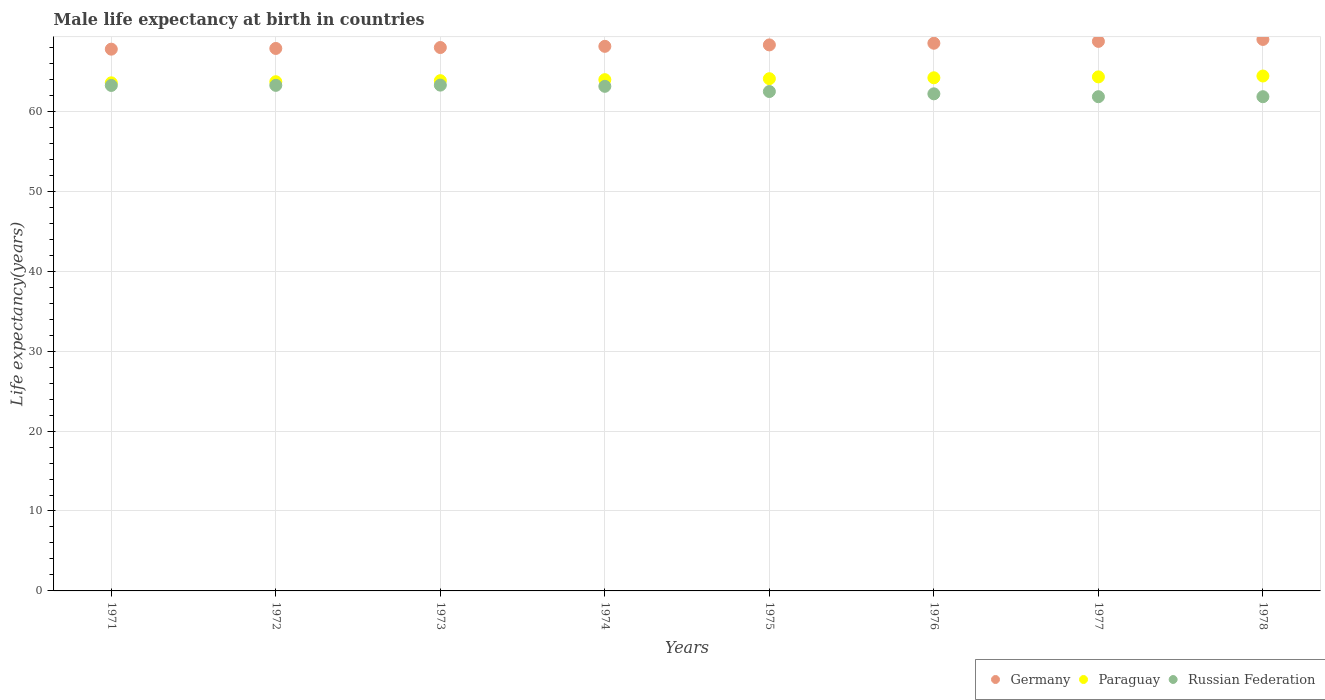What is the male life expectancy at birth in Russian Federation in 1971?
Provide a short and direct response. 63.24. Across all years, what is the maximum male life expectancy at birth in Paraguay?
Your answer should be very brief. 64.42. Across all years, what is the minimum male life expectancy at birth in Germany?
Ensure brevity in your answer.  67.78. In which year was the male life expectancy at birth in Germany maximum?
Your response must be concise. 1978. What is the total male life expectancy at birth in Germany in the graph?
Provide a short and direct response. 546.34. What is the difference between the male life expectancy at birth in Russian Federation in 1973 and that in 1978?
Keep it short and to the point. 1.45. What is the difference between the male life expectancy at birth in Russian Federation in 1973 and the male life expectancy at birth in Paraguay in 1978?
Offer a terse response. -1.14. What is the average male life expectancy at birth in Paraguay per year?
Give a very brief answer. 64.01. In the year 1978, what is the difference between the male life expectancy at birth in Paraguay and male life expectancy at birth in Russian Federation?
Offer a terse response. 2.59. What is the ratio of the male life expectancy at birth in Germany in 1974 to that in 1978?
Provide a short and direct response. 0.99. Is the male life expectancy at birth in Germany in 1972 less than that in 1974?
Keep it short and to the point. Yes. What is the difference between the highest and the second highest male life expectancy at birth in Germany?
Provide a succinct answer. 0.24. What is the difference between the highest and the lowest male life expectancy at birth in Russian Federation?
Your answer should be very brief. 1.45. In how many years, is the male life expectancy at birth in Paraguay greater than the average male life expectancy at birth in Paraguay taken over all years?
Make the answer very short. 4. Is it the case that in every year, the sum of the male life expectancy at birth in Germany and male life expectancy at birth in Paraguay  is greater than the male life expectancy at birth in Russian Federation?
Make the answer very short. Yes. Is the male life expectancy at birth in Germany strictly greater than the male life expectancy at birth in Russian Federation over the years?
Provide a succinct answer. Yes. Is the male life expectancy at birth in Russian Federation strictly less than the male life expectancy at birth in Germany over the years?
Offer a terse response. Yes. How many dotlines are there?
Your response must be concise. 3. How many years are there in the graph?
Ensure brevity in your answer.  8. What is the difference between two consecutive major ticks on the Y-axis?
Your response must be concise. 10. Does the graph contain any zero values?
Offer a terse response. No. How many legend labels are there?
Your answer should be compact. 3. What is the title of the graph?
Make the answer very short. Male life expectancy at birth in countries. Does "Montenegro" appear as one of the legend labels in the graph?
Your answer should be compact. No. What is the label or title of the Y-axis?
Your answer should be compact. Life expectancy(years). What is the Life expectancy(years) of Germany in 1971?
Ensure brevity in your answer.  67.78. What is the Life expectancy(years) in Paraguay in 1971?
Your answer should be very brief. 63.57. What is the Life expectancy(years) of Russian Federation in 1971?
Your answer should be very brief. 63.24. What is the Life expectancy(years) of Germany in 1972?
Offer a very short reply. 67.87. What is the Life expectancy(years) of Paraguay in 1972?
Provide a short and direct response. 63.7. What is the Life expectancy(years) in Russian Federation in 1972?
Offer a very short reply. 63.25. What is the Life expectancy(years) of Germany in 1973?
Your answer should be compact. 67.98. What is the Life expectancy(years) in Paraguay in 1973?
Your answer should be compact. 63.84. What is the Life expectancy(years) of Russian Federation in 1973?
Provide a succinct answer. 63.28. What is the Life expectancy(years) in Germany in 1974?
Make the answer very short. 68.13. What is the Life expectancy(years) in Paraguay in 1974?
Provide a succinct answer. 63.96. What is the Life expectancy(years) of Russian Federation in 1974?
Provide a short and direct response. 63.13. What is the Life expectancy(years) in Germany in 1975?
Provide a succinct answer. 68.31. What is the Life expectancy(years) of Paraguay in 1975?
Offer a very short reply. 64.08. What is the Life expectancy(years) in Russian Federation in 1975?
Offer a very short reply. 62.48. What is the Life expectancy(years) of Germany in 1976?
Your response must be concise. 68.52. What is the Life expectancy(years) of Paraguay in 1976?
Make the answer very short. 64.2. What is the Life expectancy(years) of Russian Federation in 1976?
Offer a very short reply. 62.19. What is the Life expectancy(years) in Germany in 1977?
Ensure brevity in your answer.  68.75. What is the Life expectancy(years) of Paraguay in 1977?
Your answer should be compact. 64.31. What is the Life expectancy(years) of Russian Federation in 1977?
Your answer should be very brief. 61.83. What is the Life expectancy(years) in Germany in 1978?
Your response must be concise. 69. What is the Life expectancy(years) of Paraguay in 1978?
Your answer should be very brief. 64.42. What is the Life expectancy(years) in Russian Federation in 1978?
Make the answer very short. 61.83. Across all years, what is the maximum Life expectancy(years) in Germany?
Your response must be concise. 69. Across all years, what is the maximum Life expectancy(years) of Paraguay?
Your answer should be compact. 64.42. Across all years, what is the maximum Life expectancy(years) of Russian Federation?
Keep it short and to the point. 63.28. Across all years, what is the minimum Life expectancy(years) in Germany?
Your answer should be very brief. 67.78. Across all years, what is the minimum Life expectancy(years) of Paraguay?
Give a very brief answer. 63.57. Across all years, what is the minimum Life expectancy(years) of Russian Federation?
Offer a terse response. 61.83. What is the total Life expectancy(years) of Germany in the graph?
Provide a short and direct response. 546.34. What is the total Life expectancy(years) in Paraguay in the graph?
Offer a terse response. 512.08. What is the total Life expectancy(years) in Russian Federation in the graph?
Keep it short and to the point. 501.23. What is the difference between the Life expectancy(years) in Germany in 1971 and that in 1972?
Your answer should be compact. -0.09. What is the difference between the Life expectancy(years) in Paraguay in 1971 and that in 1972?
Provide a short and direct response. -0.14. What is the difference between the Life expectancy(years) in Russian Federation in 1971 and that in 1972?
Provide a short and direct response. -0.01. What is the difference between the Life expectancy(years) of Germany in 1971 and that in 1973?
Ensure brevity in your answer.  -0.21. What is the difference between the Life expectancy(years) of Paraguay in 1971 and that in 1973?
Your answer should be compact. -0.27. What is the difference between the Life expectancy(years) of Russian Federation in 1971 and that in 1973?
Keep it short and to the point. -0.04. What is the difference between the Life expectancy(years) in Germany in 1971 and that in 1974?
Your response must be concise. -0.35. What is the difference between the Life expectancy(years) of Paraguay in 1971 and that in 1974?
Offer a terse response. -0.4. What is the difference between the Life expectancy(years) in Russian Federation in 1971 and that in 1974?
Your answer should be compact. 0.11. What is the difference between the Life expectancy(years) of Germany in 1971 and that in 1975?
Provide a succinct answer. -0.53. What is the difference between the Life expectancy(years) in Paraguay in 1971 and that in 1975?
Offer a very short reply. -0.52. What is the difference between the Life expectancy(years) in Russian Federation in 1971 and that in 1975?
Your answer should be very brief. 0.76. What is the difference between the Life expectancy(years) of Germany in 1971 and that in 1976?
Keep it short and to the point. -0.74. What is the difference between the Life expectancy(years) of Paraguay in 1971 and that in 1976?
Offer a terse response. -0.63. What is the difference between the Life expectancy(years) in Germany in 1971 and that in 1977?
Your response must be concise. -0.97. What is the difference between the Life expectancy(years) of Paraguay in 1971 and that in 1977?
Keep it short and to the point. -0.74. What is the difference between the Life expectancy(years) in Russian Federation in 1971 and that in 1977?
Keep it short and to the point. 1.41. What is the difference between the Life expectancy(years) of Germany in 1971 and that in 1978?
Keep it short and to the point. -1.22. What is the difference between the Life expectancy(years) in Paraguay in 1971 and that in 1978?
Your answer should be compact. -0.85. What is the difference between the Life expectancy(years) of Russian Federation in 1971 and that in 1978?
Offer a terse response. 1.41. What is the difference between the Life expectancy(years) of Germany in 1972 and that in 1973?
Keep it short and to the point. -0.12. What is the difference between the Life expectancy(years) of Paraguay in 1972 and that in 1973?
Offer a very short reply. -0.13. What is the difference between the Life expectancy(years) in Russian Federation in 1972 and that in 1973?
Offer a terse response. -0.03. What is the difference between the Life expectancy(years) in Germany in 1972 and that in 1974?
Provide a short and direct response. -0.27. What is the difference between the Life expectancy(years) in Paraguay in 1972 and that in 1974?
Give a very brief answer. -0.26. What is the difference between the Life expectancy(years) of Russian Federation in 1972 and that in 1974?
Offer a very short reply. 0.12. What is the difference between the Life expectancy(years) in Germany in 1972 and that in 1975?
Your answer should be very brief. -0.44. What is the difference between the Life expectancy(years) in Paraguay in 1972 and that in 1975?
Offer a very short reply. -0.38. What is the difference between the Life expectancy(years) of Russian Federation in 1972 and that in 1975?
Offer a terse response. 0.77. What is the difference between the Life expectancy(years) in Germany in 1972 and that in 1976?
Offer a terse response. -0.65. What is the difference between the Life expectancy(years) of Paraguay in 1972 and that in 1976?
Offer a very short reply. -0.49. What is the difference between the Life expectancy(years) of Russian Federation in 1972 and that in 1976?
Offer a terse response. 1.06. What is the difference between the Life expectancy(years) in Germany in 1972 and that in 1977?
Offer a terse response. -0.88. What is the difference between the Life expectancy(years) of Paraguay in 1972 and that in 1977?
Make the answer very short. -0.61. What is the difference between the Life expectancy(years) of Russian Federation in 1972 and that in 1977?
Provide a short and direct response. 1.42. What is the difference between the Life expectancy(years) in Germany in 1972 and that in 1978?
Keep it short and to the point. -1.13. What is the difference between the Life expectancy(years) of Paraguay in 1972 and that in 1978?
Provide a succinct answer. -0.72. What is the difference between the Life expectancy(years) of Russian Federation in 1972 and that in 1978?
Your answer should be compact. 1.42. What is the difference between the Life expectancy(years) of Germany in 1973 and that in 1974?
Give a very brief answer. -0.15. What is the difference between the Life expectancy(years) in Paraguay in 1973 and that in 1974?
Make the answer very short. -0.13. What is the difference between the Life expectancy(years) in Russian Federation in 1973 and that in 1974?
Your answer should be very brief. 0.15. What is the difference between the Life expectancy(years) of Germany in 1973 and that in 1975?
Your answer should be very brief. -0.33. What is the difference between the Life expectancy(years) in Paraguay in 1973 and that in 1975?
Offer a very short reply. -0.25. What is the difference between the Life expectancy(years) in Russian Federation in 1973 and that in 1975?
Your response must be concise. 0.8. What is the difference between the Life expectancy(years) in Germany in 1973 and that in 1976?
Your answer should be very brief. -0.54. What is the difference between the Life expectancy(years) of Paraguay in 1973 and that in 1976?
Give a very brief answer. -0.36. What is the difference between the Life expectancy(years) of Russian Federation in 1973 and that in 1976?
Your answer should be very brief. 1.09. What is the difference between the Life expectancy(years) of Germany in 1973 and that in 1977?
Keep it short and to the point. -0.77. What is the difference between the Life expectancy(years) in Paraguay in 1973 and that in 1977?
Your answer should be compact. -0.47. What is the difference between the Life expectancy(years) in Russian Federation in 1973 and that in 1977?
Your answer should be very brief. 1.45. What is the difference between the Life expectancy(years) in Germany in 1973 and that in 1978?
Offer a terse response. -1.01. What is the difference between the Life expectancy(years) of Paraguay in 1973 and that in 1978?
Offer a terse response. -0.58. What is the difference between the Life expectancy(years) in Russian Federation in 1973 and that in 1978?
Keep it short and to the point. 1.45. What is the difference between the Life expectancy(years) in Germany in 1974 and that in 1975?
Keep it short and to the point. -0.18. What is the difference between the Life expectancy(years) of Paraguay in 1974 and that in 1975?
Make the answer very short. -0.12. What is the difference between the Life expectancy(years) of Russian Federation in 1974 and that in 1975?
Give a very brief answer. 0.65. What is the difference between the Life expectancy(years) in Germany in 1974 and that in 1976?
Give a very brief answer. -0.39. What is the difference between the Life expectancy(years) of Paraguay in 1974 and that in 1976?
Ensure brevity in your answer.  -0.24. What is the difference between the Life expectancy(years) of Russian Federation in 1974 and that in 1976?
Provide a short and direct response. 0.94. What is the difference between the Life expectancy(years) of Germany in 1974 and that in 1977?
Offer a very short reply. -0.62. What is the difference between the Life expectancy(years) of Paraguay in 1974 and that in 1977?
Provide a succinct answer. -0.35. What is the difference between the Life expectancy(years) in Russian Federation in 1974 and that in 1977?
Provide a short and direct response. 1.3. What is the difference between the Life expectancy(years) of Germany in 1974 and that in 1978?
Give a very brief answer. -0.86. What is the difference between the Life expectancy(years) of Paraguay in 1974 and that in 1978?
Make the answer very short. -0.46. What is the difference between the Life expectancy(years) in Germany in 1975 and that in 1976?
Your answer should be very brief. -0.21. What is the difference between the Life expectancy(years) in Paraguay in 1975 and that in 1976?
Keep it short and to the point. -0.12. What is the difference between the Life expectancy(years) of Russian Federation in 1975 and that in 1976?
Your answer should be very brief. 0.29. What is the difference between the Life expectancy(years) of Germany in 1975 and that in 1977?
Keep it short and to the point. -0.44. What is the difference between the Life expectancy(years) in Paraguay in 1975 and that in 1977?
Offer a very short reply. -0.23. What is the difference between the Life expectancy(years) of Russian Federation in 1975 and that in 1977?
Offer a terse response. 0.65. What is the difference between the Life expectancy(years) of Germany in 1975 and that in 1978?
Keep it short and to the point. -0.68. What is the difference between the Life expectancy(years) in Paraguay in 1975 and that in 1978?
Give a very brief answer. -0.34. What is the difference between the Life expectancy(years) in Russian Federation in 1975 and that in 1978?
Offer a very short reply. 0.65. What is the difference between the Life expectancy(years) in Germany in 1976 and that in 1977?
Your answer should be compact. -0.23. What is the difference between the Life expectancy(years) of Paraguay in 1976 and that in 1977?
Offer a terse response. -0.11. What is the difference between the Life expectancy(years) in Russian Federation in 1976 and that in 1977?
Your answer should be compact. 0.36. What is the difference between the Life expectancy(years) of Germany in 1976 and that in 1978?
Provide a succinct answer. -0.47. What is the difference between the Life expectancy(years) in Paraguay in 1976 and that in 1978?
Your answer should be compact. -0.22. What is the difference between the Life expectancy(years) in Russian Federation in 1976 and that in 1978?
Your answer should be very brief. 0.36. What is the difference between the Life expectancy(years) in Germany in 1977 and that in 1978?
Offer a very short reply. -0.24. What is the difference between the Life expectancy(years) in Paraguay in 1977 and that in 1978?
Your answer should be very brief. -0.11. What is the difference between the Life expectancy(years) of Germany in 1971 and the Life expectancy(years) of Paraguay in 1972?
Offer a very short reply. 4.07. What is the difference between the Life expectancy(years) in Germany in 1971 and the Life expectancy(years) in Russian Federation in 1972?
Make the answer very short. 4.53. What is the difference between the Life expectancy(years) in Paraguay in 1971 and the Life expectancy(years) in Russian Federation in 1972?
Your answer should be compact. 0.32. What is the difference between the Life expectancy(years) of Germany in 1971 and the Life expectancy(years) of Paraguay in 1973?
Your answer should be very brief. 3.94. What is the difference between the Life expectancy(years) in Germany in 1971 and the Life expectancy(years) in Russian Federation in 1973?
Your answer should be compact. 4.5. What is the difference between the Life expectancy(years) in Paraguay in 1971 and the Life expectancy(years) in Russian Federation in 1973?
Provide a short and direct response. 0.29. What is the difference between the Life expectancy(years) in Germany in 1971 and the Life expectancy(years) in Paraguay in 1974?
Provide a succinct answer. 3.82. What is the difference between the Life expectancy(years) of Germany in 1971 and the Life expectancy(years) of Russian Federation in 1974?
Keep it short and to the point. 4.65. What is the difference between the Life expectancy(years) in Paraguay in 1971 and the Life expectancy(years) in Russian Federation in 1974?
Provide a succinct answer. 0.44. What is the difference between the Life expectancy(years) in Germany in 1971 and the Life expectancy(years) in Paraguay in 1975?
Offer a terse response. 3.69. What is the difference between the Life expectancy(years) of Germany in 1971 and the Life expectancy(years) of Russian Federation in 1975?
Give a very brief answer. 5.3. What is the difference between the Life expectancy(years) in Paraguay in 1971 and the Life expectancy(years) in Russian Federation in 1975?
Give a very brief answer. 1.09. What is the difference between the Life expectancy(years) of Germany in 1971 and the Life expectancy(years) of Paraguay in 1976?
Make the answer very short. 3.58. What is the difference between the Life expectancy(years) in Germany in 1971 and the Life expectancy(years) in Russian Federation in 1976?
Your answer should be compact. 5.59. What is the difference between the Life expectancy(years) in Paraguay in 1971 and the Life expectancy(years) in Russian Federation in 1976?
Offer a very short reply. 1.38. What is the difference between the Life expectancy(years) in Germany in 1971 and the Life expectancy(years) in Paraguay in 1977?
Ensure brevity in your answer.  3.47. What is the difference between the Life expectancy(years) of Germany in 1971 and the Life expectancy(years) of Russian Federation in 1977?
Provide a succinct answer. 5.95. What is the difference between the Life expectancy(years) in Paraguay in 1971 and the Life expectancy(years) in Russian Federation in 1977?
Provide a short and direct response. 1.74. What is the difference between the Life expectancy(years) of Germany in 1971 and the Life expectancy(years) of Paraguay in 1978?
Ensure brevity in your answer.  3.36. What is the difference between the Life expectancy(years) in Germany in 1971 and the Life expectancy(years) in Russian Federation in 1978?
Provide a short and direct response. 5.95. What is the difference between the Life expectancy(years) in Paraguay in 1971 and the Life expectancy(years) in Russian Federation in 1978?
Offer a terse response. 1.74. What is the difference between the Life expectancy(years) in Germany in 1972 and the Life expectancy(years) in Paraguay in 1973?
Provide a short and direct response. 4.03. What is the difference between the Life expectancy(years) of Germany in 1972 and the Life expectancy(years) of Russian Federation in 1973?
Make the answer very short. 4.59. What is the difference between the Life expectancy(years) in Paraguay in 1972 and the Life expectancy(years) in Russian Federation in 1973?
Your answer should be very brief. 0.42. What is the difference between the Life expectancy(years) of Germany in 1972 and the Life expectancy(years) of Paraguay in 1974?
Give a very brief answer. 3.9. What is the difference between the Life expectancy(years) in Germany in 1972 and the Life expectancy(years) in Russian Federation in 1974?
Your answer should be compact. 4.74. What is the difference between the Life expectancy(years) of Paraguay in 1972 and the Life expectancy(years) of Russian Federation in 1974?
Your response must be concise. 0.57. What is the difference between the Life expectancy(years) in Germany in 1972 and the Life expectancy(years) in Paraguay in 1975?
Ensure brevity in your answer.  3.78. What is the difference between the Life expectancy(years) of Germany in 1972 and the Life expectancy(years) of Russian Federation in 1975?
Offer a very short reply. 5.39. What is the difference between the Life expectancy(years) in Paraguay in 1972 and the Life expectancy(years) in Russian Federation in 1975?
Provide a succinct answer. 1.22. What is the difference between the Life expectancy(years) of Germany in 1972 and the Life expectancy(years) of Paraguay in 1976?
Provide a short and direct response. 3.67. What is the difference between the Life expectancy(years) in Germany in 1972 and the Life expectancy(years) in Russian Federation in 1976?
Give a very brief answer. 5.68. What is the difference between the Life expectancy(years) of Paraguay in 1972 and the Life expectancy(years) of Russian Federation in 1976?
Your response must be concise. 1.51. What is the difference between the Life expectancy(years) of Germany in 1972 and the Life expectancy(years) of Paraguay in 1977?
Offer a terse response. 3.56. What is the difference between the Life expectancy(years) in Germany in 1972 and the Life expectancy(years) in Russian Federation in 1977?
Make the answer very short. 6.04. What is the difference between the Life expectancy(years) in Paraguay in 1972 and the Life expectancy(years) in Russian Federation in 1977?
Offer a very short reply. 1.87. What is the difference between the Life expectancy(years) in Germany in 1972 and the Life expectancy(years) in Paraguay in 1978?
Your response must be concise. 3.45. What is the difference between the Life expectancy(years) of Germany in 1972 and the Life expectancy(years) of Russian Federation in 1978?
Make the answer very short. 6.04. What is the difference between the Life expectancy(years) of Paraguay in 1972 and the Life expectancy(years) of Russian Federation in 1978?
Your answer should be compact. 1.87. What is the difference between the Life expectancy(years) in Germany in 1973 and the Life expectancy(years) in Paraguay in 1974?
Your answer should be very brief. 4.02. What is the difference between the Life expectancy(years) in Germany in 1973 and the Life expectancy(years) in Russian Federation in 1974?
Offer a very short reply. 4.85. What is the difference between the Life expectancy(years) in Paraguay in 1973 and the Life expectancy(years) in Russian Federation in 1974?
Offer a terse response. 0.71. What is the difference between the Life expectancy(years) of Germany in 1973 and the Life expectancy(years) of Paraguay in 1975?
Provide a short and direct response. 3.9. What is the difference between the Life expectancy(years) in Germany in 1973 and the Life expectancy(years) in Russian Federation in 1975?
Offer a terse response. 5.5. What is the difference between the Life expectancy(years) of Paraguay in 1973 and the Life expectancy(years) of Russian Federation in 1975?
Give a very brief answer. 1.36. What is the difference between the Life expectancy(years) of Germany in 1973 and the Life expectancy(years) of Paraguay in 1976?
Your answer should be very brief. 3.79. What is the difference between the Life expectancy(years) of Germany in 1973 and the Life expectancy(years) of Russian Federation in 1976?
Your answer should be very brief. 5.79. What is the difference between the Life expectancy(years) in Paraguay in 1973 and the Life expectancy(years) in Russian Federation in 1976?
Provide a short and direct response. 1.65. What is the difference between the Life expectancy(years) in Germany in 1973 and the Life expectancy(years) in Paraguay in 1977?
Your answer should be very brief. 3.67. What is the difference between the Life expectancy(years) of Germany in 1973 and the Life expectancy(years) of Russian Federation in 1977?
Offer a terse response. 6.15. What is the difference between the Life expectancy(years) of Paraguay in 1973 and the Life expectancy(years) of Russian Federation in 1977?
Offer a very short reply. 2.01. What is the difference between the Life expectancy(years) of Germany in 1973 and the Life expectancy(years) of Paraguay in 1978?
Make the answer very short. 3.56. What is the difference between the Life expectancy(years) of Germany in 1973 and the Life expectancy(years) of Russian Federation in 1978?
Your answer should be compact. 6.15. What is the difference between the Life expectancy(years) of Paraguay in 1973 and the Life expectancy(years) of Russian Federation in 1978?
Offer a terse response. 2.01. What is the difference between the Life expectancy(years) in Germany in 1974 and the Life expectancy(years) in Paraguay in 1975?
Offer a terse response. 4.05. What is the difference between the Life expectancy(years) of Germany in 1974 and the Life expectancy(years) of Russian Federation in 1975?
Provide a succinct answer. 5.65. What is the difference between the Life expectancy(years) in Paraguay in 1974 and the Life expectancy(years) in Russian Federation in 1975?
Provide a short and direct response. 1.48. What is the difference between the Life expectancy(years) in Germany in 1974 and the Life expectancy(years) in Paraguay in 1976?
Your answer should be compact. 3.93. What is the difference between the Life expectancy(years) in Germany in 1974 and the Life expectancy(years) in Russian Federation in 1976?
Ensure brevity in your answer.  5.94. What is the difference between the Life expectancy(years) in Paraguay in 1974 and the Life expectancy(years) in Russian Federation in 1976?
Ensure brevity in your answer.  1.77. What is the difference between the Life expectancy(years) of Germany in 1974 and the Life expectancy(years) of Paraguay in 1977?
Keep it short and to the point. 3.82. What is the difference between the Life expectancy(years) in Germany in 1974 and the Life expectancy(years) in Russian Federation in 1977?
Provide a succinct answer. 6.3. What is the difference between the Life expectancy(years) in Paraguay in 1974 and the Life expectancy(years) in Russian Federation in 1977?
Your answer should be compact. 2.13. What is the difference between the Life expectancy(years) in Germany in 1974 and the Life expectancy(years) in Paraguay in 1978?
Your answer should be very brief. 3.71. What is the difference between the Life expectancy(years) of Germany in 1974 and the Life expectancy(years) of Russian Federation in 1978?
Give a very brief answer. 6.3. What is the difference between the Life expectancy(years) of Paraguay in 1974 and the Life expectancy(years) of Russian Federation in 1978?
Keep it short and to the point. 2.13. What is the difference between the Life expectancy(years) in Germany in 1975 and the Life expectancy(years) in Paraguay in 1976?
Ensure brevity in your answer.  4.11. What is the difference between the Life expectancy(years) in Germany in 1975 and the Life expectancy(years) in Russian Federation in 1976?
Ensure brevity in your answer.  6.12. What is the difference between the Life expectancy(years) of Paraguay in 1975 and the Life expectancy(years) of Russian Federation in 1976?
Your response must be concise. 1.89. What is the difference between the Life expectancy(years) in Germany in 1975 and the Life expectancy(years) in Paraguay in 1977?
Your response must be concise. 4. What is the difference between the Life expectancy(years) in Germany in 1975 and the Life expectancy(years) in Russian Federation in 1977?
Provide a succinct answer. 6.48. What is the difference between the Life expectancy(years) of Paraguay in 1975 and the Life expectancy(years) of Russian Federation in 1977?
Ensure brevity in your answer.  2.25. What is the difference between the Life expectancy(years) in Germany in 1975 and the Life expectancy(years) in Paraguay in 1978?
Make the answer very short. 3.89. What is the difference between the Life expectancy(years) in Germany in 1975 and the Life expectancy(years) in Russian Federation in 1978?
Your answer should be compact. 6.48. What is the difference between the Life expectancy(years) of Paraguay in 1975 and the Life expectancy(years) of Russian Federation in 1978?
Make the answer very short. 2.25. What is the difference between the Life expectancy(years) in Germany in 1976 and the Life expectancy(years) in Paraguay in 1977?
Your answer should be very brief. 4.21. What is the difference between the Life expectancy(years) in Germany in 1976 and the Life expectancy(years) in Russian Federation in 1977?
Your answer should be very brief. 6.69. What is the difference between the Life expectancy(years) of Paraguay in 1976 and the Life expectancy(years) of Russian Federation in 1977?
Your answer should be compact. 2.37. What is the difference between the Life expectancy(years) of Germany in 1976 and the Life expectancy(years) of Paraguay in 1978?
Provide a short and direct response. 4.1. What is the difference between the Life expectancy(years) in Germany in 1976 and the Life expectancy(years) in Russian Federation in 1978?
Make the answer very short. 6.69. What is the difference between the Life expectancy(years) in Paraguay in 1976 and the Life expectancy(years) in Russian Federation in 1978?
Keep it short and to the point. 2.37. What is the difference between the Life expectancy(years) in Germany in 1977 and the Life expectancy(years) in Paraguay in 1978?
Provide a short and direct response. 4.33. What is the difference between the Life expectancy(years) in Germany in 1977 and the Life expectancy(years) in Russian Federation in 1978?
Give a very brief answer. 6.92. What is the difference between the Life expectancy(years) of Paraguay in 1977 and the Life expectancy(years) of Russian Federation in 1978?
Provide a succinct answer. 2.48. What is the average Life expectancy(years) in Germany per year?
Offer a very short reply. 68.29. What is the average Life expectancy(years) in Paraguay per year?
Offer a very short reply. 64.01. What is the average Life expectancy(years) in Russian Federation per year?
Offer a very short reply. 62.65. In the year 1971, what is the difference between the Life expectancy(years) of Germany and Life expectancy(years) of Paraguay?
Your response must be concise. 4.21. In the year 1971, what is the difference between the Life expectancy(years) in Germany and Life expectancy(years) in Russian Federation?
Keep it short and to the point. 4.54. In the year 1971, what is the difference between the Life expectancy(years) in Paraguay and Life expectancy(years) in Russian Federation?
Give a very brief answer. 0.33. In the year 1972, what is the difference between the Life expectancy(years) in Germany and Life expectancy(years) in Paraguay?
Your response must be concise. 4.16. In the year 1972, what is the difference between the Life expectancy(years) in Germany and Life expectancy(years) in Russian Federation?
Keep it short and to the point. 4.62. In the year 1972, what is the difference between the Life expectancy(years) of Paraguay and Life expectancy(years) of Russian Federation?
Ensure brevity in your answer.  0.45. In the year 1973, what is the difference between the Life expectancy(years) of Germany and Life expectancy(years) of Paraguay?
Provide a short and direct response. 4.15. In the year 1973, what is the difference between the Life expectancy(years) in Germany and Life expectancy(years) in Russian Federation?
Provide a short and direct response. 4.7. In the year 1973, what is the difference between the Life expectancy(years) of Paraguay and Life expectancy(years) of Russian Federation?
Keep it short and to the point. 0.56. In the year 1974, what is the difference between the Life expectancy(years) of Germany and Life expectancy(years) of Paraguay?
Keep it short and to the point. 4.17. In the year 1974, what is the difference between the Life expectancy(years) of Germany and Life expectancy(years) of Russian Federation?
Provide a succinct answer. 5. In the year 1974, what is the difference between the Life expectancy(years) of Paraguay and Life expectancy(years) of Russian Federation?
Ensure brevity in your answer.  0.83. In the year 1975, what is the difference between the Life expectancy(years) of Germany and Life expectancy(years) of Paraguay?
Offer a very short reply. 4.23. In the year 1975, what is the difference between the Life expectancy(years) of Germany and Life expectancy(years) of Russian Federation?
Make the answer very short. 5.83. In the year 1975, what is the difference between the Life expectancy(years) in Paraguay and Life expectancy(years) in Russian Federation?
Your answer should be very brief. 1.6. In the year 1976, what is the difference between the Life expectancy(years) in Germany and Life expectancy(years) in Paraguay?
Offer a terse response. 4.32. In the year 1976, what is the difference between the Life expectancy(years) in Germany and Life expectancy(years) in Russian Federation?
Keep it short and to the point. 6.33. In the year 1976, what is the difference between the Life expectancy(years) in Paraguay and Life expectancy(years) in Russian Federation?
Your answer should be very brief. 2.01. In the year 1977, what is the difference between the Life expectancy(years) of Germany and Life expectancy(years) of Paraguay?
Provide a short and direct response. 4.44. In the year 1977, what is the difference between the Life expectancy(years) in Germany and Life expectancy(years) in Russian Federation?
Your answer should be compact. 6.92. In the year 1977, what is the difference between the Life expectancy(years) in Paraguay and Life expectancy(years) in Russian Federation?
Make the answer very short. 2.48. In the year 1978, what is the difference between the Life expectancy(years) of Germany and Life expectancy(years) of Paraguay?
Offer a terse response. 4.58. In the year 1978, what is the difference between the Life expectancy(years) of Germany and Life expectancy(years) of Russian Federation?
Make the answer very short. 7.17. In the year 1978, what is the difference between the Life expectancy(years) in Paraguay and Life expectancy(years) in Russian Federation?
Keep it short and to the point. 2.59. What is the ratio of the Life expectancy(years) in Germany in 1971 to that in 1972?
Keep it short and to the point. 1. What is the ratio of the Life expectancy(years) of Paraguay in 1971 to that in 1972?
Your answer should be compact. 1. What is the ratio of the Life expectancy(years) of Russian Federation in 1971 to that in 1972?
Keep it short and to the point. 1. What is the ratio of the Life expectancy(years) in Germany in 1971 to that in 1974?
Provide a succinct answer. 0.99. What is the ratio of the Life expectancy(years) in Paraguay in 1971 to that in 1974?
Your answer should be compact. 0.99. What is the ratio of the Life expectancy(years) of Russian Federation in 1971 to that in 1974?
Make the answer very short. 1. What is the ratio of the Life expectancy(years) of Germany in 1971 to that in 1975?
Provide a succinct answer. 0.99. What is the ratio of the Life expectancy(years) of Paraguay in 1971 to that in 1975?
Offer a terse response. 0.99. What is the ratio of the Life expectancy(years) of Russian Federation in 1971 to that in 1975?
Provide a succinct answer. 1.01. What is the ratio of the Life expectancy(years) of Germany in 1971 to that in 1976?
Offer a terse response. 0.99. What is the ratio of the Life expectancy(years) in Paraguay in 1971 to that in 1976?
Ensure brevity in your answer.  0.99. What is the ratio of the Life expectancy(years) of Russian Federation in 1971 to that in 1976?
Give a very brief answer. 1.02. What is the ratio of the Life expectancy(years) of Germany in 1971 to that in 1977?
Offer a terse response. 0.99. What is the ratio of the Life expectancy(years) of Paraguay in 1971 to that in 1977?
Provide a succinct answer. 0.99. What is the ratio of the Life expectancy(years) in Russian Federation in 1971 to that in 1977?
Provide a succinct answer. 1.02. What is the ratio of the Life expectancy(years) in Germany in 1971 to that in 1978?
Give a very brief answer. 0.98. What is the ratio of the Life expectancy(years) in Russian Federation in 1971 to that in 1978?
Your answer should be very brief. 1.02. What is the ratio of the Life expectancy(years) in Paraguay in 1972 to that in 1973?
Give a very brief answer. 1. What is the ratio of the Life expectancy(years) of Russian Federation in 1972 to that in 1973?
Your answer should be compact. 1. What is the ratio of the Life expectancy(years) in Russian Federation in 1972 to that in 1974?
Ensure brevity in your answer.  1. What is the ratio of the Life expectancy(years) of Russian Federation in 1972 to that in 1975?
Make the answer very short. 1.01. What is the ratio of the Life expectancy(years) of Paraguay in 1972 to that in 1976?
Your response must be concise. 0.99. What is the ratio of the Life expectancy(years) of Germany in 1972 to that in 1977?
Provide a short and direct response. 0.99. What is the ratio of the Life expectancy(years) of Paraguay in 1972 to that in 1977?
Ensure brevity in your answer.  0.99. What is the ratio of the Life expectancy(years) in Germany in 1972 to that in 1978?
Your response must be concise. 0.98. What is the ratio of the Life expectancy(years) of Paraguay in 1972 to that in 1978?
Your response must be concise. 0.99. What is the ratio of the Life expectancy(years) in Paraguay in 1973 to that in 1974?
Provide a succinct answer. 1. What is the ratio of the Life expectancy(years) in Russian Federation in 1973 to that in 1974?
Ensure brevity in your answer.  1. What is the ratio of the Life expectancy(years) in Germany in 1973 to that in 1975?
Your response must be concise. 1. What is the ratio of the Life expectancy(years) in Paraguay in 1973 to that in 1975?
Keep it short and to the point. 1. What is the ratio of the Life expectancy(years) of Russian Federation in 1973 to that in 1975?
Offer a terse response. 1.01. What is the ratio of the Life expectancy(years) of Germany in 1973 to that in 1976?
Give a very brief answer. 0.99. What is the ratio of the Life expectancy(years) in Russian Federation in 1973 to that in 1976?
Your response must be concise. 1.02. What is the ratio of the Life expectancy(years) in Russian Federation in 1973 to that in 1977?
Your answer should be very brief. 1.02. What is the ratio of the Life expectancy(years) of Paraguay in 1973 to that in 1978?
Ensure brevity in your answer.  0.99. What is the ratio of the Life expectancy(years) of Russian Federation in 1973 to that in 1978?
Keep it short and to the point. 1.02. What is the ratio of the Life expectancy(years) of Russian Federation in 1974 to that in 1975?
Your response must be concise. 1.01. What is the ratio of the Life expectancy(years) in Germany in 1974 to that in 1976?
Provide a short and direct response. 0.99. What is the ratio of the Life expectancy(years) in Paraguay in 1974 to that in 1976?
Offer a terse response. 1. What is the ratio of the Life expectancy(years) in Russian Federation in 1974 to that in 1976?
Provide a succinct answer. 1.02. What is the ratio of the Life expectancy(years) in Germany in 1974 to that in 1977?
Your answer should be very brief. 0.99. What is the ratio of the Life expectancy(years) in Russian Federation in 1974 to that in 1977?
Keep it short and to the point. 1.02. What is the ratio of the Life expectancy(years) of Germany in 1974 to that in 1978?
Your answer should be very brief. 0.99. What is the ratio of the Life expectancy(years) of Russian Federation in 1975 to that in 1976?
Your response must be concise. 1. What is the ratio of the Life expectancy(years) of Germany in 1975 to that in 1977?
Make the answer very short. 0.99. What is the ratio of the Life expectancy(years) in Russian Federation in 1975 to that in 1977?
Give a very brief answer. 1.01. What is the ratio of the Life expectancy(years) of Germany in 1975 to that in 1978?
Your answer should be compact. 0.99. What is the ratio of the Life expectancy(years) of Russian Federation in 1975 to that in 1978?
Keep it short and to the point. 1.01. What is the ratio of the Life expectancy(years) in Russian Federation in 1976 to that in 1977?
Offer a terse response. 1.01. What is the ratio of the Life expectancy(years) in Germany in 1976 to that in 1978?
Ensure brevity in your answer.  0.99. What is the ratio of the Life expectancy(years) in Paraguay in 1976 to that in 1978?
Give a very brief answer. 1. What is the ratio of the Life expectancy(years) in Paraguay in 1977 to that in 1978?
Offer a very short reply. 1. What is the ratio of the Life expectancy(years) of Russian Federation in 1977 to that in 1978?
Your response must be concise. 1. What is the difference between the highest and the second highest Life expectancy(years) in Germany?
Provide a short and direct response. 0.24. What is the difference between the highest and the second highest Life expectancy(years) of Paraguay?
Offer a very short reply. 0.11. What is the difference between the highest and the lowest Life expectancy(years) of Germany?
Give a very brief answer. 1.22. What is the difference between the highest and the lowest Life expectancy(years) of Paraguay?
Your answer should be compact. 0.85. What is the difference between the highest and the lowest Life expectancy(years) of Russian Federation?
Offer a very short reply. 1.45. 